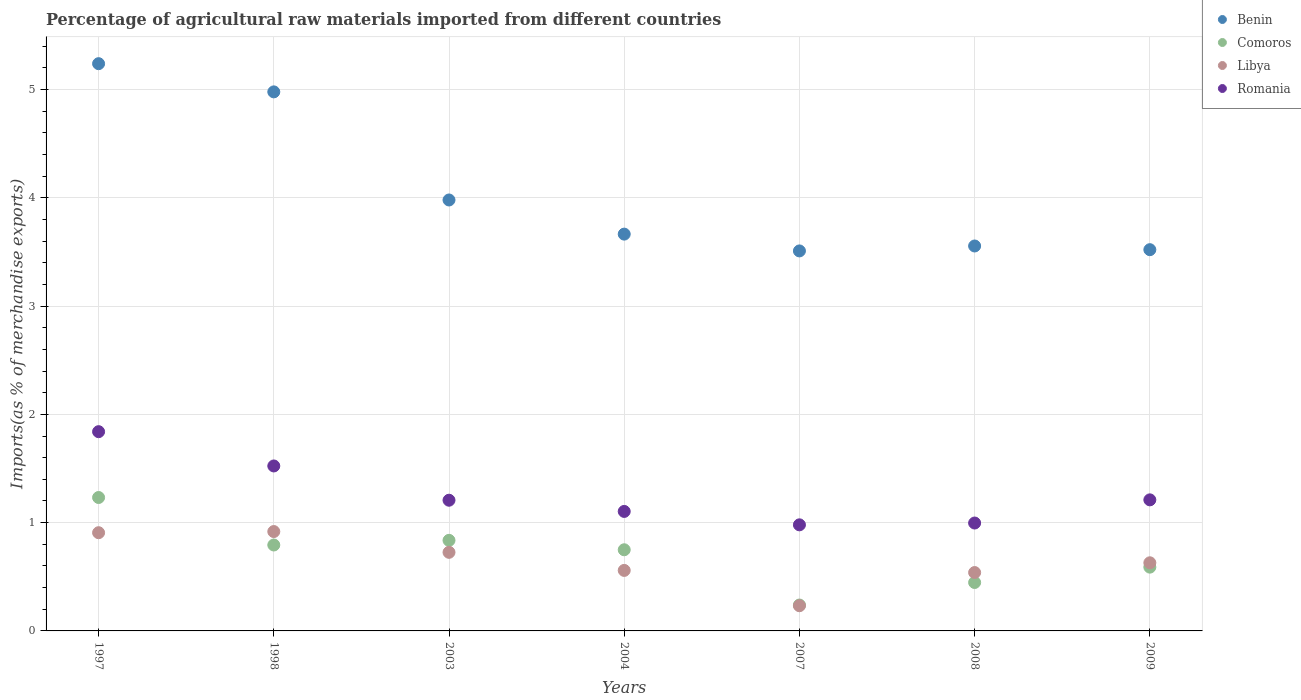What is the percentage of imports to different countries in Romania in 2003?
Offer a very short reply. 1.21. Across all years, what is the maximum percentage of imports to different countries in Benin?
Your response must be concise. 5.24. Across all years, what is the minimum percentage of imports to different countries in Romania?
Keep it short and to the point. 0.98. In which year was the percentage of imports to different countries in Benin maximum?
Provide a succinct answer. 1997. What is the total percentage of imports to different countries in Libya in the graph?
Provide a succinct answer. 4.51. What is the difference between the percentage of imports to different countries in Romania in 1998 and that in 2008?
Ensure brevity in your answer.  0.53. What is the difference between the percentage of imports to different countries in Comoros in 1997 and the percentage of imports to different countries in Benin in 2009?
Keep it short and to the point. -2.29. What is the average percentage of imports to different countries in Romania per year?
Your answer should be compact. 1.27. In the year 2009, what is the difference between the percentage of imports to different countries in Romania and percentage of imports to different countries in Libya?
Offer a terse response. 0.58. What is the ratio of the percentage of imports to different countries in Comoros in 1997 to that in 2004?
Offer a very short reply. 1.64. What is the difference between the highest and the second highest percentage of imports to different countries in Benin?
Provide a short and direct response. 0.26. What is the difference between the highest and the lowest percentage of imports to different countries in Benin?
Offer a very short reply. 1.73. In how many years, is the percentage of imports to different countries in Libya greater than the average percentage of imports to different countries in Libya taken over all years?
Make the answer very short. 3. Is the sum of the percentage of imports to different countries in Comoros in 1997 and 2004 greater than the maximum percentage of imports to different countries in Benin across all years?
Offer a terse response. No. Is it the case that in every year, the sum of the percentage of imports to different countries in Libya and percentage of imports to different countries in Benin  is greater than the sum of percentage of imports to different countries in Comoros and percentage of imports to different countries in Romania?
Your response must be concise. Yes. Is it the case that in every year, the sum of the percentage of imports to different countries in Libya and percentage of imports to different countries in Romania  is greater than the percentage of imports to different countries in Comoros?
Your answer should be compact. Yes. Does the percentage of imports to different countries in Comoros monotonically increase over the years?
Keep it short and to the point. No. Is the percentage of imports to different countries in Romania strictly greater than the percentage of imports to different countries in Comoros over the years?
Offer a terse response. Yes. How many years are there in the graph?
Keep it short and to the point. 7. Does the graph contain grids?
Your response must be concise. Yes. Where does the legend appear in the graph?
Provide a short and direct response. Top right. How are the legend labels stacked?
Ensure brevity in your answer.  Vertical. What is the title of the graph?
Ensure brevity in your answer.  Percentage of agricultural raw materials imported from different countries. What is the label or title of the X-axis?
Offer a very short reply. Years. What is the label or title of the Y-axis?
Give a very brief answer. Imports(as % of merchandise exports). What is the Imports(as % of merchandise exports) of Benin in 1997?
Your answer should be compact. 5.24. What is the Imports(as % of merchandise exports) in Comoros in 1997?
Ensure brevity in your answer.  1.23. What is the Imports(as % of merchandise exports) of Libya in 1997?
Give a very brief answer. 0.91. What is the Imports(as % of merchandise exports) in Romania in 1997?
Give a very brief answer. 1.84. What is the Imports(as % of merchandise exports) in Benin in 1998?
Offer a terse response. 4.98. What is the Imports(as % of merchandise exports) of Comoros in 1998?
Make the answer very short. 0.79. What is the Imports(as % of merchandise exports) of Libya in 1998?
Ensure brevity in your answer.  0.92. What is the Imports(as % of merchandise exports) in Romania in 1998?
Give a very brief answer. 1.52. What is the Imports(as % of merchandise exports) in Benin in 2003?
Make the answer very short. 3.98. What is the Imports(as % of merchandise exports) in Comoros in 2003?
Your answer should be compact. 0.84. What is the Imports(as % of merchandise exports) in Libya in 2003?
Give a very brief answer. 0.73. What is the Imports(as % of merchandise exports) of Romania in 2003?
Your response must be concise. 1.21. What is the Imports(as % of merchandise exports) of Benin in 2004?
Offer a very short reply. 3.66. What is the Imports(as % of merchandise exports) of Comoros in 2004?
Your answer should be very brief. 0.75. What is the Imports(as % of merchandise exports) of Libya in 2004?
Keep it short and to the point. 0.56. What is the Imports(as % of merchandise exports) in Romania in 2004?
Keep it short and to the point. 1.1. What is the Imports(as % of merchandise exports) in Benin in 2007?
Offer a very short reply. 3.51. What is the Imports(as % of merchandise exports) of Comoros in 2007?
Make the answer very short. 0.24. What is the Imports(as % of merchandise exports) in Libya in 2007?
Your answer should be very brief. 0.23. What is the Imports(as % of merchandise exports) of Romania in 2007?
Your answer should be very brief. 0.98. What is the Imports(as % of merchandise exports) in Benin in 2008?
Offer a terse response. 3.56. What is the Imports(as % of merchandise exports) of Comoros in 2008?
Offer a very short reply. 0.45. What is the Imports(as % of merchandise exports) of Libya in 2008?
Offer a terse response. 0.54. What is the Imports(as % of merchandise exports) in Romania in 2008?
Your response must be concise. 1. What is the Imports(as % of merchandise exports) in Benin in 2009?
Your answer should be very brief. 3.52. What is the Imports(as % of merchandise exports) of Comoros in 2009?
Keep it short and to the point. 0.59. What is the Imports(as % of merchandise exports) in Libya in 2009?
Your response must be concise. 0.63. What is the Imports(as % of merchandise exports) of Romania in 2009?
Give a very brief answer. 1.21. Across all years, what is the maximum Imports(as % of merchandise exports) in Benin?
Offer a terse response. 5.24. Across all years, what is the maximum Imports(as % of merchandise exports) of Comoros?
Provide a short and direct response. 1.23. Across all years, what is the maximum Imports(as % of merchandise exports) of Libya?
Your answer should be compact. 0.92. Across all years, what is the maximum Imports(as % of merchandise exports) in Romania?
Your response must be concise. 1.84. Across all years, what is the minimum Imports(as % of merchandise exports) in Benin?
Your answer should be very brief. 3.51. Across all years, what is the minimum Imports(as % of merchandise exports) in Comoros?
Provide a succinct answer. 0.24. Across all years, what is the minimum Imports(as % of merchandise exports) of Libya?
Give a very brief answer. 0.23. Across all years, what is the minimum Imports(as % of merchandise exports) of Romania?
Provide a succinct answer. 0.98. What is the total Imports(as % of merchandise exports) in Benin in the graph?
Provide a short and direct response. 28.45. What is the total Imports(as % of merchandise exports) in Comoros in the graph?
Offer a terse response. 4.89. What is the total Imports(as % of merchandise exports) in Libya in the graph?
Make the answer very short. 4.51. What is the total Imports(as % of merchandise exports) of Romania in the graph?
Give a very brief answer. 8.86. What is the difference between the Imports(as % of merchandise exports) of Benin in 1997 and that in 1998?
Make the answer very short. 0.26. What is the difference between the Imports(as % of merchandise exports) in Comoros in 1997 and that in 1998?
Provide a short and direct response. 0.44. What is the difference between the Imports(as % of merchandise exports) in Libya in 1997 and that in 1998?
Your answer should be compact. -0.01. What is the difference between the Imports(as % of merchandise exports) in Romania in 1997 and that in 1998?
Make the answer very short. 0.32. What is the difference between the Imports(as % of merchandise exports) in Benin in 1997 and that in 2003?
Your answer should be compact. 1.26. What is the difference between the Imports(as % of merchandise exports) in Comoros in 1997 and that in 2003?
Provide a short and direct response. 0.4. What is the difference between the Imports(as % of merchandise exports) in Libya in 1997 and that in 2003?
Provide a short and direct response. 0.18. What is the difference between the Imports(as % of merchandise exports) of Romania in 1997 and that in 2003?
Provide a short and direct response. 0.63. What is the difference between the Imports(as % of merchandise exports) in Benin in 1997 and that in 2004?
Keep it short and to the point. 1.57. What is the difference between the Imports(as % of merchandise exports) in Comoros in 1997 and that in 2004?
Give a very brief answer. 0.48. What is the difference between the Imports(as % of merchandise exports) of Libya in 1997 and that in 2004?
Your answer should be very brief. 0.35. What is the difference between the Imports(as % of merchandise exports) of Romania in 1997 and that in 2004?
Offer a very short reply. 0.74. What is the difference between the Imports(as % of merchandise exports) of Benin in 1997 and that in 2007?
Your answer should be very brief. 1.73. What is the difference between the Imports(as % of merchandise exports) of Libya in 1997 and that in 2007?
Your answer should be compact. 0.67. What is the difference between the Imports(as % of merchandise exports) of Romania in 1997 and that in 2007?
Your answer should be compact. 0.86. What is the difference between the Imports(as % of merchandise exports) in Benin in 1997 and that in 2008?
Ensure brevity in your answer.  1.68. What is the difference between the Imports(as % of merchandise exports) of Comoros in 1997 and that in 2008?
Make the answer very short. 0.79. What is the difference between the Imports(as % of merchandise exports) of Libya in 1997 and that in 2008?
Give a very brief answer. 0.37. What is the difference between the Imports(as % of merchandise exports) of Romania in 1997 and that in 2008?
Keep it short and to the point. 0.84. What is the difference between the Imports(as % of merchandise exports) of Benin in 1997 and that in 2009?
Offer a very short reply. 1.72. What is the difference between the Imports(as % of merchandise exports) in Comoros in 1997 and that in 2009?
Make the answer very short. 0.64. What is the difference between the Imports(as % of merchandise exports) of Libya in 1997 and that in 2009?
Your answer should be very brief. 0.28. What is the difference between the Imports(as % of merchandise exports) in Romania in 1997 and that in 2009?
Your answer should be very brief. 0.63. What is the difference between the Imports(as % of merchandise exports) in Comoros in 1998 and that in 2003?
Make the answer very short. -0.04. What is the difference between the Imports(as % of merchandise exports) in Libya in 1998 and that in 2003?
Give a very brief answer. 0.19. What is the difference between the Imports(as % of merchandise exports) of Romania in 1998 and that in 2003?
Make the answer very short. 0.32. What is the difference between the Imports(as % of merchandise exports) in Benin in 1998 and that in 2004?
Ensure brevity in your answer.  1.31. What is the difference between the Imports(as % of merchandise exports) in Comoros in 1998 and that in 2004?
Your answer should be compact. 0.04. What is the difference between the Imports(as % of merchandise exports) in Libya in 1998 and that in 2004?
Provide a short and direct response. 0.36. What is the difference between the Imports(as % of merchandise exports) of Romania in 1998 and that in 2004?
Your answer should be compact. 0.42. What is the difference between the Imports(as % of merchandise exports) of Benin in 1998 and that in 2007?
Offer a terse response. 1.47. What is the difference between the Imports(as % of merchandise exports) in Comoros in 1998 and that in 2007?
Your response must be concise. 0.55. What is the difference between the Imports(as % of merchandise exports) in Libya in 1998 and that in 2007?
Ensure brevity in your answer.  0.69. What is the difference between the Imports(as % of merchandise exports) of Romania in 1998 and that in 2007?
Give a very brief answer. 0.54. What is the difference between the Imports(as % of merchandise exports) of Benin in 1998 and that in 2008?
Make the answer very short. 1.42. What is the difference between the Imports(as % of merchandise exports) of Comoros in 1998 and that in 2008?
Make the answer very short. 0.35. What is the difference between the Imports(as % of merchandise exports) of Libya in 1998 and that in 2008?
Your response must be concise. 0.38. What is the difference between the Imports(as % of merchandise exports) of Romania in 1998 and that in 2008?
Give a very brief answer. 0.53. What is the difference between the Imports(as % of merchandise exports) in Benin in 1998 and that in 2009?
Keep it short and to the point. 1.46. What is the difference between the Imports(as % of merchandise exports) in Comoros in 1998 and that in 2009?
Keep it short and to the point. 0.2. What is the difference between the Imports(as % of merchandise exports) of Libya in 1998 and that in 2009?
Ensure brevity in your answer.  0.29. What is the difference between the Imports(as % of merchandise exports) of Romania in 1998 and that in 2009?
Offer a terse response. 0.31. What is the difference between the Imports(as % of merchandise exports) in Benin in 2003 and that in 2004?
Keep it short and to the point. 0.32. What is the difference between the Imports(as % of merchandise exports) in Comoros in 2003 and that in 2004?
Your response must be concise. 0.09. What is the difference between the Imports(as % of merchandise exports) in Libya in 2003 and that in 2004?
Ensure brevity in your answer.  0.17. What is the difference between the Imports(as % of merchandise exports) in Romania in 2003 and that in 2004?
Offer a very short reply. 0.1. What is the difference between the Imports(as % of merchandise exports) of Benin in 2003 and that in 2007?
Make the answer very short. 0.47. What is the difference between the Imports(as % of merchandise exports) of Comoros in 2003 and that in 2007?
Keep it short and to the point. 0.6. What is the difference between the Imports(as % of merchandise exports) of Libya in 2003 and that in 2007?
Provide a succinct answer. 0.49. What is the difference between the Imports(as % of merchandise exports) of Romania in 2003 and that in 2007?
Offer a terse response. 0.23. What is the difference between the Imports(as % of merchandise exports) in Benin in 2003 and that in 2008?
Provide a short and direct response. 0.42. What is the difference between the Imports(as % of merchandise exports) of Comoros in 2003 and that in 2008?
Give a very brief answer. 0.39. What is the difference between the Imports(as % of merchandise exports) of Libya in 2003 and that in 2008?
Offer a very short reply. 0.19. What is the difference between the Imports(as % of merchandise exports) of Romania in 2003 and that in 2008?
Give a very brief answer. 0.21. What is the difference between the Imports(as % of merchandise exports) in Benin in 2003 and that in 2009?
Provide a succinct answer. 0.46. What is the difference between the Imports(as % of merchandise exports) of Comoros in 2003 and that in 2009?
Offer a very short reply. 0.25. What is the difference between the Imports(as % of merchandise exports) in Libya in 2003 and that in 2009?
Your response must be concise. 0.1. What is the difference between the Imports(as % of merchandise exports) in Romania in 2003 and that in 2009?
Ensure brevity in your answer.  -0. What is the difference between the Imports(as % of merchandise exports) in Benin in 2004 and that in 2007?
Offer a terse response. 0.16. What is the difference between the Imports(as % of merchandise exports) of Comoros in 2004 and that in 2007?
Ensure brevity in your answer.  0.51. What is the difference between the Imports(as % of merchandise exports) of Libya in 2004 and that in 2007?
Your response must be concise. 0.33. What is the difference between the Imports(as % of merchandise exports) of Romania in 2004 and that in 2007?
Keep it short and to the point. 0.12. What is the difference between the Imports(as % of merchandise exports) in Benin in 2004 and that in 2008?
Give a very brief answer. 0.11. What is the difference between the Imports(as % of merchandise exports) of Comoros in 2004 and that in 2008?
Ensure brevity in your answer.  0.3. What is the difference between the Imports(as % of merchandise exports) in Libya in 2004 and that in 2008?
Give a very brief answer. 0.02. What is the difference between the Imports(as % of merchandise exports) in Romania in 2004 and that in 2008?
Your response must be concise. 0.11. What is the difference between the Imports(as % of merchandise exports) in Benin in 2004 and that in 2009?
Your response must be concise. 0.14. What is the difference between the Imports(as % of merchandise exports) of Comoros in 2004 and that in 2009?
Provide a succinct answer. 0.16. What is the difference between the Imports(as % of merchandise exports) in Libya in 2004 and that in 2009?
Offer a terse response. -0.07. What is the difference between the Imports(as % of merchandise exports) in Romania in 2004 and that in 2009?
Provide a succinct answer. -0.11. What is the difference between the Imports(as % of merchandise exports) in Benin in 2007 and that in 2008?
Your answer should be very brief. -0.05. What is the difference between the Imports(as % of merchandise exports) of Comoros in 2007 and that in 2008?
Your response must be concise. -0.21. What is the difference between the Imports(as % of merchandise exports) in Libya in 2007 and that in 2008?
Keep it short and to the point. -0.31. What is the difference between the Imports(as % of merchandise exports) in Romania in 2007 and that in 2008?
Make the answer very short. -0.02. What is the difference between the Imports(as % of merchandise exports) in Benin in 2007 and that in 2009?
Your answer should be compact. -0.01. What is the difference between the Imports(as % of merchandise exports) in Comoros in 2007 and that in 2009?
Your answer should be very brief. -0.35. What is the difference between the Imports(as % of merchandise exports) of Libya in 2007 and that in 2009?
Ensure brevity in your answer.  -0.4. What is the difference between the Imports(as % of merchandise exports) of Romania in 2007 and that in 2009?
Keep it short and to the point. -0.23. What is the difference between the Imports(as % of merchandise exports) of Benin in 2008 and that in 2009?
Offer a very short reply. 0.03. What is the difference between the Imports(as % of merchandise exports) of Comoros in 2008 and that in 2009?
Offer a terse response. -0.14. What is the difference between the Imports(as % of merchandise exports) in Libya in 2008 and that in 2009?
Your answer should be compact. -0.09. What is the difference between the Imports(as % of merchandise exports) of Romania in 2008 and that in 2009?
Ensure brevity in your answer.  -0.21. What is the difference between the Imports(as % of merchandise exports) in Benin in 1997 and the Imports(as % of merchandise exports) in Comoros in 1998?
Your response must be concise. 4.45. What is the difference between the Imports(as % of merchandise exports) of Benin in 1997 and the Imports(as % of merchandise exports) of Libya in 1998?
Provide a succinct answer. 4.32. What is the difference between the Imports(as % of merchandise exports) in Benin in 1997 and the Imports(as % of merchandise exports) in Romania in 1998?
Ensure brevity in your answer.  3.72. What is the difference between the Imports(as % of merchandise exports) of Comoros in 1997 and the Imports(as % of merchandise exports) of Libya in 1998?
Ensure brevity in your answer.  0.31. What is the difference between the Imports(as % of merchandise exports) in Comoros in 1997 and the Imports(as % of merchandise exports) in Romania in 1998?
Give a very brief answer. -0.29. What is the difference between the Imports(as % of merchandise exports) in Libya in 1997 and the Imports(as % of merchandise exports) in Romania in 1998?
Keep it short and to the point. -0.62. What is the difference between the Imports(as % of merchandise exports) in Benin in 1997 and the Imports(as % of merchandise exports) in Comoros in 2003?
Your answer should be compact. 4.4. What is the difference between the Imports(as % of merchandise exports) in Benin in 1997 and the Imports(as % of merchandise exports) in Libya in 2003?
Your response must be concise. 4.51. What is the difference between the Imports(as % of merchandise exports) in Benin in 1997 and the Imports(as % of merchandise exports) in Romania in 2003?
Provide a succinct answer. 4.03. What is the difference between the Imports(as % of merchandise exports) of Comoros in 1997 and the Imports(as % of merchandise exports) of Libya in 2003?
Make the answer very short. 0.51. What is the difference between the Imports(as % of merchandise exports) in Comoros in 1997 and the Imports(as % of merchandise exports) in Romania in 2003?
Provide a short and direct response. 0.03. What is the difference between the Imports(as % of merchandise exports) in Libya in 1997 and the Imports(as % of merchandise exports) in Romania in 2003?
Make the answer very short. -0.3. What is the difference between the Imports(as % of merchandise exports) in Benin in 1997 and the Imports(as % of merchandise exports) in Comoros in 2004?
Provide a succinct answer. 4.49. What is the difference between the Imports(as % of merchandise exports) in Benin in 1997 and the Imports(as % of merchandise exports) in Libya in 2004?
Keep it short and to the point. 4.68. What is the difference between the Imports(as % of merchandise exports) in Benin in 1997 and the Imports(as % of merchandise exports) in Romania in 2004?
Make the answer very short. 4.14. What is the difference between the Imports(as % of merchandise exports) of Comoros in 1997 and the Imports(as % of merchandise exports) of Libya in 2004?
Ensure brevity in your answer.  0.67. What is the difference between the Imports(as % of merchandise exports) of Comoros in 1997 and the Imports(as % of merchandise exports) of Romania in 2004?
Your response must be concise. 0.13. What is the difference between the Imports(as % of merchandise exports) of Libya in 1997 and the Imports(as % of merchandise exports) of Romania in 2004?
Provide a short and direct response. -0.2. What is the difference between the Imports(as % of merchandise exports) in Benin in 1997 and the Imports(as % of merchandise exports) in Comoros in 2007?
Offer a terse response. 5. What is the difference between the Imports(as % of merchandise exports) of Benin in 1997 and the Imports(as % of merchandise exports) of Libya in 2007?
Provide a short and direct response. 5.01. What is the difference between the Imports(as % of merchandise exports) of Benin in 1997 and the Imports(as % of merchandise exports) of Romania in 2007?
Make the answer very short. 4.26. What is the difference between the Imports(as % of merchandise exports) of Comoros in 1997 and the Imports(as % of merchandise exports) of Libya in 2007?
Make the answer very short. 1. What is the difference between the Imports(as % of merchandise exports) of Comoros in 1997 and the Imports(as % of merchandise exports) of Romania in 2007?
Your answer should be compact. 0.25. What is the difference between the Imports(as % of merchandise exports) of Libya in 1997 and the Imports(as % of merchandise exports) of Romania in 2007?
Ensure brevity in your answer.  -0.07. What is the difference between the Imports(as % of merchandise exports) in Benin in 1997 and the Imports(as % of merchandise exports) in Comoros in 2008?
Your response must be concise. 4.79. What is the difference between the Imports(as % of merchandise exports) of Benin in 1997 and the Imports(as % of merchandise exports) of Libya in 2008?
Offer a very short reply. 4.7. What is the difference between the Imports(as % of merchandise exports) in Benin in 1997 and the Imports(as % of merchandise exports) in Romania in 2008?
Provide a succinct answer. 4.24. What is the difference between the Imports(as % of merchandise exports) in Comoros in 1997 and the Imports(as % of merchandise exports) in Libya in 2008?
Offer a very short reply. 0.69. What is the difference between the Imports(as % of merchandise exports) in Comoros in 1997 and the Imports(as % of merchandise exports) in Romania in 2008?
Your answer should be compact. 0.24. What is the difference between the Imports(as % of merchandise exports) in Libya in 1997 and the Imports(as % of merchandise exports) in Romania in 2008?
Offer a terse response. -0.09. What is the difference between the Imports(as % of merchandise exports) in Benin in 1997 and the Imports(as % of merchandise exports) in Comoros in 2009?
Offer a very short reply. 4.65. What is the difference between the Imports(as % of merchandise exports) of Benin in 1997 and the Imports(as % of merchandise exports) of Libya in 2009?
Your answer should be compact. 4.61. What is the difference between the Imports(as % of merchandise exports) of Benin in 1997 and the Imports(as % of merchandise exports) of Romania in 2009?
Offer a very short reply. 4.03. What is the difference between the Imports(as % of merchandise exports) in Comoros in 1997 and the Imports(as % of merchandise exports) in Libya in 2009?
Your answer should be compact. 0.6. What is the difference between the Imports(as % of merchandise exports) in Comoros in 1997 and the Imports(as % of merchandise exports) in Romania in 2009?
Keep it short and to the point. 0.02. What is the difference between the Imports(as % of merchandise exports) in Libya in 1997 and the Imports(as % of merchandise exports) in Romania in 2009?
Make the answer very short. -0.3. What is the difference between the Imports(as % of merchandise exports) in Benin in 1998 and the Imports(as % of merchandise exports) in Comoros in 2003?
Keep it short and to the point. 4.14. What is the difference between the Imports(as % of merchandise exports) of Benin in 1998 and the Imports(as % of merchandise exports) of Libya in 2003?
Your answer should be compact. 4.25. What is the difference between the Imports(as % of merchandise exports) of Benin in 1998 and the Imports(as % of merchandise exports) of Romania in 2003?
Ensure brevity in your answer.  3.77. What is the difference between the Imports(as % of merchandise exports) of Comoros in 1998 and the Imports(as % of merchandise exports) of Libya in 2003?
Your response must be concise. 0.07. What is the difference between the Imports(as % of merchandise exports) in Comoros in 1998 and the Imports(as % of merchandise exports) in Romania in 2003?
Your answer should be very brief. -0.41. What is the difference between the Imports(as % of merchandise exports) in Libya in 1998 and the Imports(as % of merchandise exports) in Romania in 2003?
Give a very brief answer. -0.29. What is the difference between the Imports(as % of merchandise exports) in Benin in 1998 and the Imports(as % of merchandise exports) in Comoros in 2004?
Provide a succinct answer. 4.23. What is the difference between the Imports(as % of merchandise exports) in Benin in 1998 and the Imports(as % of merchandise exports) in Libya in 2004?
Your response must be concise. 4.42. What is the difference between the Imports(as % of merchandise exports) in Benin in 1998 and the Imports(as % of merchandise exports) in Romania in 2004?
Give a very brief answer. 3.87. What is the difference between the Imports(as % of merchandise exports) in Comoros in 1998 and the Imports(as % of merchandise exports) in Libya in 2004?
Your response must be concise. 0.23. What is the difference between the Imports(as % of merchandise exports) in Comoros in 1998 and the Imports(as % of merchandise exports) in Romania in 2004?
Your answer should be very brief. -0.31. What is the difference between the Imports(as % of merchandise exports) of Libya in 1998 and the Imports(as % of merchandise exports) of Romania in 2004?
Provide a succinct answer. -0.19. What is the difference between the Imports(as % of merchandise exports) of Benin in 1998 and the Imports(as % of merchandise exports) of Comoros in 2007?
Provide a short and direct response. 4.74. What is the difference between the Imports(as % of merchandise exports) of Benin in 1998 and the Imports(as % of merchandise exports) of Libya in 2007?
Offer a terse response. 4.75. What is the difference between the Imports(as % of merchandise exports) in Benin in 1998 and the Imports(as % of merchandise exports) in Romania in 2007?
Provide a succinct answer. 4. What is the difference between the Imports(as % of merchandise exports) in Comoros in 1998 and the Imports(as % of merchandise exports) in Libya in 2007?
Offer a very short reply. 0.56. What is the difference between the Imports(as % of merchandise exports) of Comoros in 1998 and the Imports(as % of merchandise exports) of Romania in 2007?
Provide a succinct answer. -0.19. What is the difference between the Imports(as % of merchandise exports) of Libya in 1998 and the Imports(as % of merchandise exports) of Romania in 2007?
Your answer should be compact. -0.06. What is the difference between the Imports(as % of merchandise exports) in Benin in 1998 and the Imports(as % of merchandise exports) in Comoros in 2008?
Offer a very short reply. 4.53. What is the difference between the Imports(as % of merchandise exports) in Benin in 1998 and the Imports(as % of merchandise exports) in Libya in 2008?
Your response must be concise. 4.44. What is the difference between the Imports(as % of merchandise exports) in Benin in 1998 and the Imports(as % of merchandise exports) in Romania in 2008?
Your response must be concise. 3.98. What is the difference between the Imports(as % of merchandise exports) of Comoros in 1998 and the Imports(as % of merchandise exports) of Libya in 2008?
Give a very brief answer. 0.25. What is the difference between the Imports(as % of merchandise exports) of Comoros in 1998 and the Imports(as % of merchandise exports) of Romania in 2008?
Your response must be concise. -0.2. What is the difference between the Imports(as % of merchandise exports) in Libya in 1998 and the Imports(as % of merchandise exports) in Romania in 2008?
Offer a very short reply. -0.08. What is the difference between the Imports(as % of merchandise exports) of Benin in 1998 and the Imports(as % of merchandise exports) of Comoros in 2009?
Your answer should be very brief. 4.39. What is the difference between the Imports(as % of merchandise exports) in Benin in 1998 and the Imports(as % of merchandise exports) in Libya in 2009?
Your answer should be compact. 4.35. What is the difference between the Imports(as % of merchandise exports) of Benin in 1998 and the Imports(as % of merchandise exports) of Romania in 2009?
Give a very brief answer. 3.77. What is the difference between the Imports(as % of merchandise exports) of Comoros in 1998 and the Imports(as % of merchandise exports) of Libya in 2009?
Your response must be concise. 0.16. What is the difference between the Imports(as % of merchandise exports) in Comoros in 1998 and the Imports(as % of merchandise exports) in Romania in 2009?
Keep it short and to the point. -0.42. What is the difference between the Imports(as % of merchandise exports) of Libya in 1998 and the Imports(as % of merchandise exports) of Romania in 2009?
Give a very brief answer. -0.29. What is the difference between the Imports(as % of merchandise exports) in Benin in 2003 and the Imports(as % of merchandise exports) in Comoros in 2004?
Give a very brief answer. 3.23. What is the difference between the Imports(as % of merchandise exports) of Benin in 2003 and the Imports(as % of merchandise exports) of Libya in 2004?
Provide a short and direct response. 3.42. What is the difference between the Imports(as % of merchandise exports) of Benin in 2003 and the Imports(as % of merchandise exports) of Romania in 2004?
Provide a succinct answer. 2.88. What is the difference between the Imports(as % of merchandise exports) of Comoros in 2003 and the Imports(as % of merchandise exports) of Libya in 2004?
Your response must be concise. 0.28. What is the difference between the Imports(as % of merchandise exports) in Comoros in 2003 and the Imports(as % of merchandise exports) in Romania in 2004?
Keep it short and to the point. -0.27. What is the difference between the Imports(as % of merchandise exports) of Libya in 2003 and the Imports(as % of merchandise exports) of Romania in 2004?
Your response must be concise. -0.38. What is the difference between the Imports(as % of merchandise exports) of Benin in 2003 and the Imports(as % of merchandise exports) of Comoros in 2007?
Make the answer very short. 3.74. What is the difference between the Imports(as % of merchandise exports) in Benin in 2003 and the Imports(as % of merchandise exports) in Libya in 2007?
Give a very brief answer. 3.75. What is the difference between the Imports(as % of merchandise exports) in Benin in 2003 and the Imports(as % of merchandise exports) in Romania in 2007?
Your answer should be compact. 3. What is the difference between the Imports(as % of merchandise exports) of Comoros in 2003 and the Imports(as % of merchandise exports) of Libya in 2007?
Offer a terse response. 0.6. What is the difference between the Imports(as % of merchandise exports) in Comoros in 2003 and the Imports(as % of merchandise exports) in Romania in 2007?
Offer a terse response. -0.14. What is the difference between the Imports(as % of merchandise exports) of Libya in 2003 and the Imports(as % of merchandise exports) of Romania in 2007?
Offer a terse response. -0.25. What is the difference between the Imports(as % of merchandise exports) of Benin in 2003 and the Imports(as % of merchandise exports) of Comoros in 2008?
Your answer should be compact. 3.53. What is the difference between the Imports(as % of merchandise exports) of Benin in 2003 and the Imports(as % of merchandise exports) of Libya in 2008?
Give a very brief answer. 3.44. What is the difference between the Imports(as % of merchandise exports) of Benin in 2003 and the Imports(as % of merchandise exports) of Romania in 2008?
Offer a terse response. 2.98. What is the difference between the Imports(as % of merchandise exports) of Comoros in 2003 and the Imports(as % of merchandise exports) of Libya in 2008?
Provide a short and direct response. 0.3. What is the difference between the Imports(as % of merchandise exports) of Comoros in 2003 and the Imports(as % of merchandise exports) of Romania in 2008?
Offer a very short reply. -0.16. What is the difference between the Imports(as % of merchandise exports) in Libya in 2003 and the Imports(as % of merchandise exports) in Romania in 2008?
Provide a short and direct response. -0.27. What is the difference between the Imports(as % of merchandise exports) of Benin in 2003 and the Imports(as % of merchandise exports) of Comoros in 2009?
Offer a terse response. 3.39. What is the difference between the Imports(as % of merchandise exports) of Benin in 2003 and the Imports(as % of merchandise exports) of Libya in 2009?
Your response must be concise. 3.35. What is the difference between the Imports(as % of merchandise exports) in Benin in 2003 and the Imports(as % of merchandise exports) in Romania in 2009?
Provide a succinct answer. 2.77. What is the difference between the Imports(as % of merchandise exports) of Comoros in 2003 and the Imports(as % of merchandise exports) of Libya in 2009?
Give a very brief answer. 0.21. What is the difference between the Imports(as % of merchandise exports) of Comoros in 2003 and the Imports(as % of merchandise exports) of Romania in 2009?
Your response must be concise. -0.37. What is the difference between the Imports(as % of merchandise exports) of Libya in 2003 and the Imports(as % of merchandise exports) of Romania in 2009?
Give a very brief answer. -0.48. What is the difference between the Imports(as % of merchandise exports) of Benin in 2004 and the Imports(as % of merchandise exports) of Comoros in 2007?
Give a very brief answer. 3.43. What is the difference between the Imports(as % of merchandise exports) in Benin in 2004 and the Imports(as % of merchandise exports) in Libya in 2007?
Provide a succinct answer. 3.43. What is the difference between the Imports(as % of merchandise exports) of Benin in 2004 and the Imports(as % of merchandise exports) of Romania in 2007?
Keep it short and to the point. 2.68. What is the difference between the Imports(as % of merchandise exports) in Comoros in 2004 and the Imports(as % of merchandise exports) in Libya in 2007?
Make the answer very short. 0.52. What is the difference between the Imports(as % of merchandise exports) in Comoros in 2004 and the Imports(as % of merchandise exports) in Romania in 2007?
Ensure brevity in your answer.  -0.23. What is the difference between the Imports(as % of merchandise exports) in Libya in 2004 and the Imports(as % of merchandise exports) in Romania in 2007?
Keep it short and to the point. -0.42. What is the difference between the Imports(as % of merchandise exports) in Benin in 2004 and the Imports(as % of merchandise exports) in Comoros in 2008?
Make the answer very short. 3.22. What is the difference between the Imports(as % of merchandise exports) of Benin in 2004 and the Imports(as % of merchandise exports) of Libya in 2008?
Your answer should be very brief. 3.13. What is the difference between the Imports(as % of merchandise exports) in Benin in 2004 and the Imports(as % of merchandise exports) in Romania in 2008?
Keep it short and to the point. 2.67. What is the difference between the Imports(as % of merchandise exports) of Comoros in 2004 and the Imports(as % of merchandise exports) of Libya in 2008?
Keep it short and to the point. 0.21. What is the difference between the Imports(as % of merchandise exports) of Comoros in 2004 and the Imports(as % of merchandise exports) of Romania in 2008?
Your answer should be compact. -0.25. What is the difference between the Imports(as % of merchandise exports) in Libya in 2004 and the Imports(as % of merchandise exports) in Romania in 2008?
Give a very brief answer. -0.44. What is the difference between the Imports(as % of merchandise exports) in Benin in 2004 and the Imports(as % of merchandise exports) in Comoros in 2009?
Ensure brevity in your answer.  3.08. What is the difference between the Imports(as % of merchandise exports) of Benin in 2004 and the Imports(as % of merchandise exports) of Libya in 2009?
Offer a terse response. 3.04. What is the difference between the Imports(as % of merchandise exports) of Benin in 2004 and the Imports(as % of merchandise exports) of Romania in 2009?
Your answer should be compact. 2.45. What is the difference between the Imports(as % of merchandise exports) in Comoros in 2004 and the Imports(as % of merchandise exports) in Libya in 2009?
Provide a succinct answer. 0.12. What is the difference between the Imports(as % of merchandise exports) in Comoros in 2004 and the Imports(as % of merchandise exports) in Romania in 2009?
Your answer should be compact. -0.46. What is the difference between the Imports(as % of merchandise exports) of Libya in 2004 and the Imports(as % of merchandise exports) of Romania in 2009?
Provide a short and direct response. -0.65. What is the difference between the Imports(as % of merchandise exports) of Benin in 2007 and the Imports(as % of merchandise exports) of Comoros in 2008?
Give a very brief answer. 3.06. What is the difference between the Imports(as % of merchandise exports) of Benin in 2007 and the Imports(as % of merchandise exports) of Libya in 2008?
Your answer should be compact. 2.97. What is the difference between the Imports(as % of merchandise exports) in Benin in 2007 and the Imports(as % of merchandise exports) in Romania in 2008?
Keep it short and to the point. 2.51. What is the difference between the Imports(as % of merchandise exports) of Comoros in 2007 and the Imports(as % of merchandise exports) of Libya in 2008?
Offer a terse response. -0.3. What is the difference between the Imports(as % of merchandise exports) of Comoros in 2007 and the Imports(as % of merchandise exports) of Romania in 2008?
Your answer should be compact. -0.76. What is the difference between the Imports(as % of merchandise exports) in Libya in 2007 and the Imports(as % of merchandise exports) in Romania in 2008?
Your answer should be compact. -0.76. What is the difference between the Imports(as % of merchandise exports) of Benin in 2007 and the Imports(as % of merchandise exports) of Comoros in 2009?
Your answer should be very brief. 2.92. What is the difference between the Imports(as % of merchandise exports) of Benin in 2007 and the Imports(as % of merchandise exports) of Libya in 2009?
Give a very brief answer. 2.88. What is the difference between the Imports(as % of merchandise exports) of Benin in 2007 and the Imports(as % of merchandise exports) of Romania in 2009?
Give a very brief answer. 2.3. What is the difference between the Imports(as % of merchandise exports) of Comoros in 2007 and the Imports(as % of merchandise exports) of Libya in 2009?
Make the answer very short. -0.39. What is the difference between the Imports(as % of merchandise exports) in Comoros in 2007 and the Imports(as % of merchandise exports) in Romania in 2009?
Ensure brevity in your answer.  -0.97. What is the difference between the Imports(as % of merchandise exports) in Libya in 2007 and the Imports(as % of merchandise exports) in Romania in 2009?
Provide a short and direct response. -0.98. What is the difference between the Imports(as % of merchandise exports) of Benin in 2008 and the Imports(as % of merchandise exports) of Comoros in 2009?
Your response must be concise. 2.97. What is the difference between the Imports(as % of merchandise exports) in Benin in 2008 and the Imports(as % of merchandise exports) in Libya in 2009?
Provide a short and direct response. 2.93. What is the difference between the Imports(as % of merchandise exports) of Benin in 2008 and the Imports(as % of merchandise exports) of Romania in 2009?
Keep it short and to the point. 2.34. What is the difference between the Imports(as % of merchandise exports) in Comoros in 2008 and the Imports(as % of merchandise exports) in Libya in 2009?
Your response must be concise. -0.18. What is the difference between the Imports(as % of merchandise exports) in Comoros in 2008 and the Imports(as % of merchandise exports) in Romania in 2009?
Provide a succinct answer. -0.76. What is the difference between the Imports(as % of merchandise exports) of Libya in 2008 and the Imports(as % of merchandise exports) of Romania in 2009?
Keep it short and to the point. -0.67. What is the average Imports(as % of merchandise exports) of Benin per year?
Make the answer very short. 4.06. What is the average Imports(as % of merchandise exports) of Comoros per year?
Offer a terse response. 0.7. What is the average Imports(as % of merchandise exports) in Libya per year?
Your answer should be compact. 0.64. What is the average Imports(as % of merchandise exports) of Romania per year?
Provide a short and direct response. 1.27. In the year 1997, what is the difference between the Imports(as % of merchandise exports) in Benin and Imports(as % of merchandise exports) in Comoros?
Your answer should be very brief. 4.01. In the year 1997, what is the difference between the Imports(as % of merchandise exports) of Benin and Imports(as % of merchandise exports) of Libya?
Offer a terse response. 4.33. In the year 1997, what is the difference between the Imports(as % of merchandise exports) in Benin and Imports(as % of merchandise exports) in Romania?
Your answer should be compact. 3.4. In the year 1997, what is the difference between the Imports(as % of merchandise exports) of Comoros and Imports(as % of merchandise exports) of Libya?
Keep it short and to the point. 0.33. In the year 1997, what is the difference between the Imports(as % of merchandise exports) in Comoros and Imports(as % of merchandise exports) in Romania?
Offer a very short reply. -0.61. In the year 1997, what is the difference between the Imports(as % of merchandise exports) in Libya and Imports(as % of merchandise exports) in Romania?
Provide a succinct answer. -0.93. In the year 1998, what is the difference between the Imports(as % of merchandise exports) in Benin and Imports(as % of merchandise exports) in Comoros?
Ensure brevity in your answer.  4.18. In the year 1998, what is the difference between the Imports(as % of merchandise exports) of Benin and Imports(as % of merchandise exports) of Libya?
Make the answer very short. 4.06. In the year 1998, what is the difference between the Imports(as % of merchandise exports) of Benin and Imports(as % of merchandise exports) of Romania?
Provide a short and direct response. 3.46. In the year 1998, what is the difference between the Imports(as % of merchandise exports) of Comoros and Imports(as % of merchandise exports) of Libya?
Your answer should be very brief. -0.12. In the year 1998, what is the difference between the Imports(as % of merchandise exports) of Comoros and Imports(as % of merchandise exports) of Romania?
Your answer should be compact. -0.73. In the year 1998, what is the difference between the Imports(as % of merchandise exports) of Libya and Imports(as % of merchandise exports) of Romania?
Your response must be concise. -0.61. In the year 2003, what is the difference between the Imports(as % of merchandise exports) of Benin and Imports(as % of merchandise exports) of Comoros?
Provide a short and direct response. 3.14. In the year 2003, what is the difference between the Imports(as % of merchandise exports) of Benin and Imports(as % of merchandise exports) of Libya?
Provide a short and direct response. 3.25. In the year 2003, what is the difference between the Imports(as % of merchandise exports) of Benin and Imports(as % of merchandise exports) of Romania?
Your answer should be compact. 2.77. In the year 2003, what is the difference between the Imports(as % of merchandise exports) of Comoros and Imports(as % of merchandise exports) of Libya?
Keep it short and to the point. 0.11. In the year 2003, what is the difference between the Imports(as % of merchandise exports) in Comoros and Imports(as % of merchandise exports) in Romania?
Offer a terse response. -0.37. In the year 2003, what is the difference between the Imports(as % of merchandise exports) of Libya and Imports(as % of merchandise exports) of Romania?
Offer a terse response. -0.48. In the year 2004, what is the difference between the Imports(as % of merchandise exports) in Benin and Imports(as % of merchandise exports) in Comoros?
Offer a very short reply. 2.92. In the year 2004, what is the difference between the Imports(as % of merchandise exports) in Benin and Imports(as % of merchandise exports) in Libya?
Provide a succinct answer. 3.11. In the year 2004, what is the difference between the Imports(as % of merchandise exports) in Benin and Imports(as % of merchandise exports) in Romania?
Your answer should be very brief. 2.56. In the year 2004, what is the difference between the Imports(as % of merchandise exports) of Comoros and Imports(as % of merchandise exports) of Libya?
Ensure brevity in your answer.  0.19. In the year 2004, what is the difference between the Imports(as % of merchandise exports) of Comoros and Imports(as % of merchandise exports) of Romania?
Provide a succinct answer. -0.35. In the year 2004, what is the difference between the Imports(as % of merchandise exports) in Libya and Imports(as % of merchandise exports) in Romania?
Make the answer very short. -0.54. In the year 2007, what is the difference between the Imports(as % of merchandise exports) in Benin and Imports(as % of merchandise exports) in Comoros?
Ensure brevity in your answer.  3.27. In the year 2007, what is the difference between the Imports(as % of merchandise exports) of Benin and Imports(as % of merchandise exports) of Libya?
Make the answer very short. 3.28. In the year 2007, what is the difference between the Imports(as % of merchandise exports) in Benin and Imports(as % of merchandise exports) in Romania?
Offer a very short reply. 2.53. In the year 2007, what is the difference between the Imports(as % of merchandise exports) in Comoros and Imports(as % of merchandise exports) in Libya?
Your response must be concise. 0.01. In the year 2007, what is the difference between the Imports(as % of merchandise exports) in Comoros and Imports(as % of merchandise exports) in Romania?
Your answer should be very brief. -0.74. In the year 2007, what is the difference between the Imports(as % of merchandise exports) in Libya and Imports(as % of merchandise exports) in Romania?
Offer a very short reply. -0.75. In the year 2008, what is the difference between the Imports(as % of merchandise exports) in Benin and Imports(as % of merchandise exports) in Comoros?
Keep it short and to the point. 3.11. In the year 2008, what is the difference between the Imports(as % of merchandise exports) in Benin and Imports(as % of merchandise exports) in Libya?
Provide a short and direct response. 3.02. In the year 2008, what is the difference between the Imports(as % of merchandise exports) in Benin and Imports(as % of merchandise exports) in Romania?
Keep it short and to the point. 2.56. In the year 2008, what is the difference between the Imports(as % of merchandise exports) in Comoros and Imports(as % of merchandise exports) in Libya?
Keep it short and to the point. -0.09. In the year 2008, what is the difference between the Imports(as % of merchandise exports) in Comoros and Imports(as % of merchandise exports) in Romania?
Make the answer very short. -0.55. In the year 2008, what is the difference between the Imports(as % of merchandise exports) of Libya and Imports(as % of merchandise exports) of Romania?
Offer a terse response. -0.46. In the year 2009, what is the difference between the Imports(as % of merchandise exports) in Benin and Imports(as % of merchandise exports) in Comoros?
Make the answer very short. 2.93. In the year 2009, what is the difference between the Imports(as % of merchandise exports) in Benin and Imports(as % of merchandise exports) in Libya?
Ensure brevity in your answer.  2.89. In the year 2009, what is the difference between the Imports(as % of merchandise exports) of Benin and Imports(as % of merchandise exports) of Romania?
Provide a succinct answer. 2.31. In the year 2009, what is the difference between the Imports(as % of merchandise exports) of Comoros and Imports(as % of merchandise exports) of Libya?
Offer a terse response. -0.04. In the year 2009, what is the difference between the Imports(as % of merchandise exports) in Comoros and Imports(as % of merchandise exports) in Romania?
Offer a terse response. -0.62. In the year 2009, what is the difference between the Imports(as % of merchandise exports) in Libya and Imports(as % of merchandise exports) in Romania?
Keep it short and to the point. -0.58. What is the ratio of the Imports(as % of merchandise exports) of Benin in 1997 to that in 1998?
Your answer should be very brief. 1.05. What is the ratio of the Imports(as % of merchandise exports) in Comoros in 1997 to that in 1998?
Give a very brief answer. 1.55. What is the ratio of the Imports(as % of merchandise exports) of Libya in 1997 to that in 1998?
Ensure brevity in your answer.  0.99. What is the ratio of the Imports(as % of merchandise exports) of Romania in 1997 to that in 1998?
Keep it short and to the point. 1.21. What is the ratio of the Imports(as % of merchandise exports) in Benin in 1997 to that in 2003?
Ensure brevity in your answer.  1.32. What is the ratio of the Imports(as % of merchandise exports) of Comoros in 1997 to that in 2003?
Offer a very short reply. 1.47. What is the ratio of the Imports(as % of merchandise exports) in Libya in 1997 to that in 2003?
Your response must be concise. 1.25. What is the ratio of the Imports(as % of merchandise exports) of Romania in 1997 to that in 2003?
Offer a very short reply. 1.52. What is the ratio of the Imports(as % of merchandise exports) in Benin in 1997 to that in 2004?
Provide a succinct answer. 1.43. What is the ratio of the Imports(as % of merchandise exports) of Comoros in 1997 to that in 2004?
Make the answer very short. 1.64. What is the ratio of the Imports(as % of merchandise exports) in Libya in 1997 to that in 2004?
Make the answer very short. 1.62. What is the ratio of the Imports(as % of merchandise exports) in Romania in 1997 to that in 2004?
Offer a very short reply. 1.67. What is the ratio of the Imports(as % of merchandise exports) of Benin in 1997 to that in 2007?
Your answer should be very brief. 1.49. What is the ratio of the Imports(as % of merchandise exports) in Comoros in 1997 to that in 2007?
Your response must be concise. 5.15. What is the ratio of the Imports(as % of merchandise exports) of Libya in 1997 to that in 2007?
Offer a very short reply. 3.9. What is the ratio of the Imports(as % of merchandise exports) in Romania in 1997 to that in 2007?
Provide a succinct answer. 1.88. What is the ratio of the Imports(as % of merchandise exports) of Benin in 1997 to that in 2008?
Your answer should be very brief. 1.47. What is the ratio of the Imports(as % of merchandise exports) of Comoros in 1997 to that in 2008?
Offer a terse response. 2.76. What is the ratio of the Imports(as % of merchandise exports) in Libya in 1997 to that in 2008?
Your answer should be very brief. 1.68. What is the ratio of the Imports(as % of merchandise exports) in Romania in 1997 to that in 2008?
Make the answer very short. 1.85. What is the ratio of the Imports(as % of merchandise exports) of Benin in 1997 to that in 2009?
Offer a terse response. 1.49. What is the ratio of the Imports(as % of merchandise exports) in Comoros in 1997 to that in 2009?
Give a very brief answer. 2.09. What is the ratio of the Imports(as % of merchandise exports) in Libya in 1997 to that in 2009?
Give a very brief answer. 1.44. What is the ratio of the Imports(as % of merchandise exports) in Romania in 1997 to that in 2009?
Your response must be concise. 1.52. What is the ratio of the Imports(as % of merchandise exports) in Benin in 1998 to that in 2003?
Give a very brief answer. 1.25. What is the ratio of the Imports(as % of merchandise exports) of Comoros in 1998 to that in 2003?
Your answer should be compact. 0.95. What is the ratio of the Imports(as % of merchandise exports) of Libya in 1998 to that in 2003?
Your answer should be very brief. 1.26. What is the ratio of the Imports(as % of merchandise exports) of Romania in 1998 to that in 2003?
Your response must be concise. 1.26. What is the ratio of the Imports(as % of merchandise exports) in Benin in 1998 to that in 2004?
Keep it short and to the point. 1.36. What is the ratio of the Imports(as % of merchandise exports) of Comoros in 1998 to that in 2004?
Provide a short and direct response. 1.06. What is the ratio of the Imports(as % of merchandise exports) in Libya in 1998 to that in 2004?
Your answer should be compact. 1.64. What is the ratio of the Imports(as % of merchandise exports) of Romania in 1998 to that in 2004?
Keep it short and to the point. 1.38. What is the ratio of the Imports(as % of merchandise exports) in Benin in 1998 to that in 2007?
Ensure brevity in your answer.  1.42. What is the ratio of the Imports(as % of merchandise exports) of Comoros in 1998 to that in 2007?
Offer a very short reply. 3.32. What is the ratio of the Imports(as % of merchandise exports) of Libya in 1998 to that in 2007?
Offer a very short reply. 3.94. What is the ratio of the Imports(as % of merchandise exports) of Romania in 1998 to that in 2007?
Keep it short and to the point. 1.55. What is the ratio of the Imports(as % of merchandise exports) in Benin in 1998 to that in 2008?
Your answer should be very brief. 1.4. What is the ratio of the Imports(as % of merchandise exports) in Comoros in 1998 to that in 2008?
Offer a terse response. 1.77. What is the ratio of the Imports(as % of merchandise exports) of Libya in 1998 to that in 2008?
Your answer should be very brief. 1.7. What is the ratio of the Imports(as % of merchandise exports) in Romania in 1998 to that in 2008?
Offer a very short reply. 1.53. What is the ratio of the Imports(as % of merchandise exports) of Benin in 1998 to that in 2009?
Provide a short and direct response. 1.41. What is the ratio of the Imports(as % of merchandise exports) of Comoros in 1998 to that in 2009?
Give a very brief answer. 1.35. What is the ratio of the Imports(as % of merchandise exports) in Libya in 1998 to that in 2009?
Provide a short and direct response. 1.46. What is the ratio of the Imports(as % of merchandise exports) of Romania in 1998 to that in 2009?
Ensure brevity in your answer.  1.26. What is the ratio of the Imports(as % of merchandise exports) in Benin in 2003 to that in 2004?
Make the answer very short. 1.09. What is the ratio of the Imports(as % of merchandise exports) of Comoros in 2003 to that in 2004?
Your response must be concise. 1.12. What is the ratio of the Imports(as % of merchandise exports) of Libya in 2003 to that in 2004?
Ensure brevity in your answer.  1.3. What is the ratio of the Imports(as % of merchandise exports) of Romania in 2003 to that in 2004?
Offer a very short reply. 1.09. What is the ratio of the Imports(as % of merchandise exports) of Benin in 2003 to that in 2007?
Keep it short and to the point. 1.13. What is the ratio of the Imports(as % of merchandise exports) of Comoros in 2003 to that in 2007?
Give a very brief answer. 3.5. What is the ratio of the Imports(as % of merchandise exports) of Libya in 2003 to that in 2007?
Provide a succinct answer. 3.12. What is the ratio of the Imports(as % of merchandise exports) of Romania in 2003 to that in 2007?
Make the answer very short. 1.23. What is the ratio of the Imports(as % of merchandise exports) in Benin in 2003 to that in 2008?
Provide a succinct answer. 1.12. What is the ratio of the Imports(as % of merchandise exports) of Comoros in 2003 to that in 2008?
Make the answer very short. 1.87. What is the ratio of the Imports(as % of merchandise exports) in Libya in 2003 to that in 2008?
Provide a short and direct response. 1.35. What is the ratio of the Imports(as % of merchandise exports) of Romania in 2003 to that in 2008?
Keep it short and to the point. 1.21. What is the ratio of the Imports(as % of merchandise exports) in Benin in 2003 to that in 2009?
Provide a succinct answer. 1.13. What is the ratio of the Imports(as % of merchandise exports) of Comoros in 2003 to that in 2009?
Offer a very short reply. 1.42. What is the ratio of the Imports(as % of merchandise exports) of Libya in 2003 to that in 2009?
Your response must be concise. 1.15. What is the ratio of the Imports(as % of merchandise exports) of Romania in 2003 to that in 2009?
Ensure brevity in your answer.  1. What is the ratio of the Imports(as % of merchandise exports) of Benin in 2004 to that in 2007?
Keep it short and to the point. 1.04. What is the ratio of the Imports(as % of merchandise exports) of Comoros in 2004 to that in 2007?
Your response must be concise. 3.14. What is the ratio of the Imports(as % of merchandise exports) of Libya in 2004 to that in 2007?
Offer a terse response. 2.4. What is the ratio of the Imports(as % of merchandise exports) of Romania in 2004 to that in 2007?
Provide a short and direct response. 1.13. What is the ratio of the Imports(as % of merchandise exports) of Benin in 2004 to that in 2008?
Give a very brief answer. 1.03. What is the ratio of the Imports(as % of merchandise exports) in Comoros in 2004 to that in 2008?
Give a very brief answer. 1.68. What is the ratio of the Imports(as % of merchandise exports) in Libya in 2004 to that in 2008?
Offer a terse response. 1.04. What is the ratio of the Imports(as % of merchandise exports) in Romania in 2004 to that in 2008?
Your response must be concise. 1.11. What is the ratio of the Imports(as % of merchandise exports) of Benin in 2004 to that in 2009?
Offer a very short reply. 1.04. What is the ratio of the Imports(as % of merchandise exports) in Comoros in 2004 to that in 2009?
Offer a very short reply. 1.27. What is the ratio of the Imports(as % of merchandise exports) in Libya in 2004 to that in 2009?
Your answer should be compact. 0.89. What is the ratio of the Imports(as % of merchandise exports) in Romania in 2004 to that in 2009?
Your answer should be very brief. 0.91. What is the ratio of the Imports(as % of merchandise exports) in Benin in 2007 to that in 2008?
Offer a very short reply. 0.99. What is the ratio of the Imports(as % of merchandise exports) in Comoros in 2007 to that in 2008?
Your answer should be very brief. 0.53. What is the ratio of the Imports(as % of merchandise exports) of Libya in 2007 to that in 2008?
Give a very brief answer. 0.43. What is the ratio of the Imports(as % of merchandise exports) in Romania in 2007 to that in 2008?
Keep it short and to the point. 0.98. What is the ratio of the Imports(as % of merchandise exports) in Benin in 2007 to that in 2009?
Your response must be concise. 1. What is the ratio of the Imports(as % of merchandise exports) of Comoros in 2007 to that in 2009?
Provide a short and direct response. 0.41. What is the ratio of the Imports(as % of merchandise exports) of Libya in 2007 to that in 2009?
Ensure brevity in your answer.  0.37. What is the ratio of the Imports(as % of merchandise exports) in Romania in 2007 to that in 2009?
Offer a very short reply. 0.81. What is the ratio of the Imports(as % of merchandise exports) of Benin in 2008 to that in 2009?
Keep it short and to the point. 1.01. What is the ratio of the Imports(as % of merchandise exports) of Comoros in 2008 to that in 2009?
Offer a terse response. 0.76. What is the ratio of the Imports(as % of merchandise exports) in Libya in 2008 to that in 2009?
Offer a very short reply. 0.86. What is the ratio of the Imports(as % of merchandise exports) in Romania in 2008 to that in 2009?
Give a very brief answer. 0.82. What is the difference between the highest and the second highest Imports(as % of merchandise exports) of Benin?
Offer a very short reply. 0.26. What is the difference between the highest and the second highest Imports(as % of merchandise exports) of Comoros?
Offer a very short reply. 0.4. What is the difference between the highest and the second highest Imports(as % of merchandise exports) in Libya?
Your answer should be compact. 0.01. What is the difference between the highest and the second highest Imports(as % of merchandise exports) of Romania?
Ensure brevity in your answer.  0.32. What is the difference between the highest and the lowest Imports(as % of merchandise exports) of Benin?
Offer a very short reply. 1.73. What is the difference between the highest and the lowest Imports(as % of merchandise exports) in Comoros?
Provide a succinct answer. 0.99. What is the difference between the highest and the lowest Imports(as % of merchandise exports) of Libya?
Give a very brief answer. 0.69. What is the difference between the highest and the lowest Imports(as % of merchandise exports) in Romania?
Ensure brevity in your answer.  0.86. 